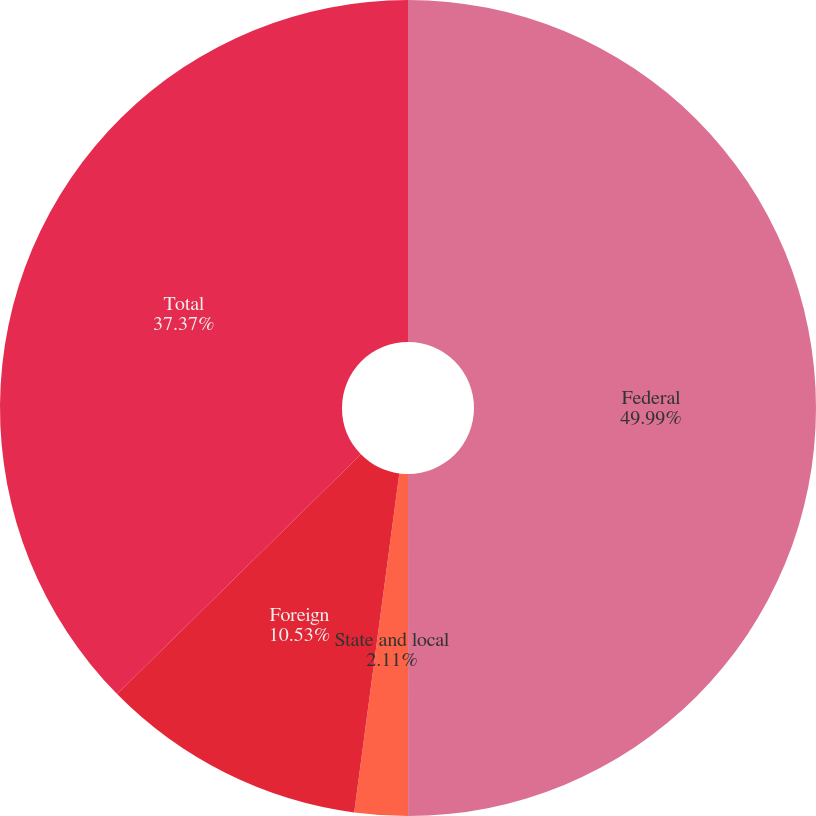Convert chart to OTSL. <chart><loc_0><loc_0><loc_500><loc_500><pie_chart><fcel>Federal<fcel>State and local<fcel>Foreign<fcel>Total<nl><fcel>50.0%<fcel>2.11%<fcel>10.53%<fcel>37.37%<nl></chart> 